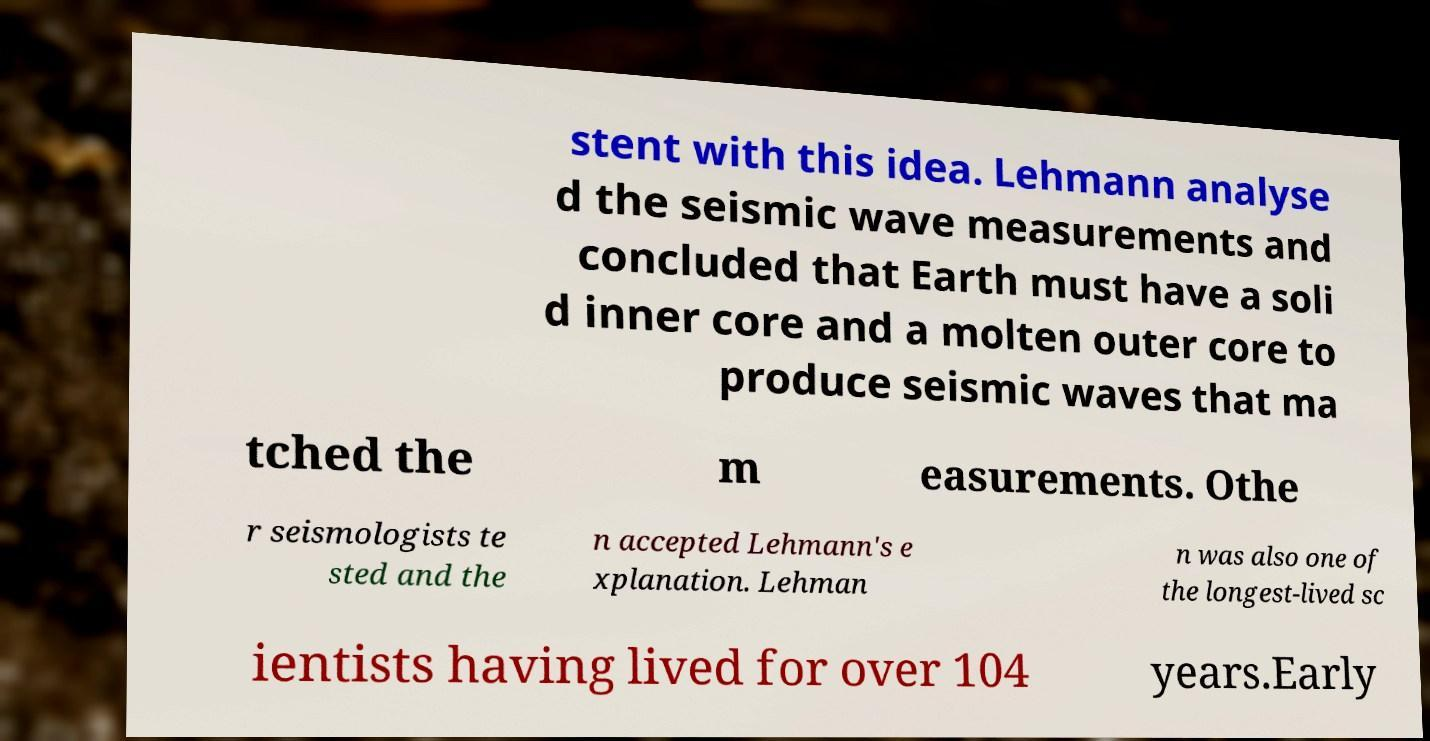Can you accurately transcribe the text from the provided image for me? stent with this idea. Lehmann analyse d the seismic wave measurements and concluded that Earth must have a soli d inner core and a molten outer core to produce seismic waves that ma tched the m easurements. Othe r seismologists te sted and the n accepted Lehmann's e xplanation. Lehman n was also one of the longest-lived sc ientists having lived for over 104 years.Early 